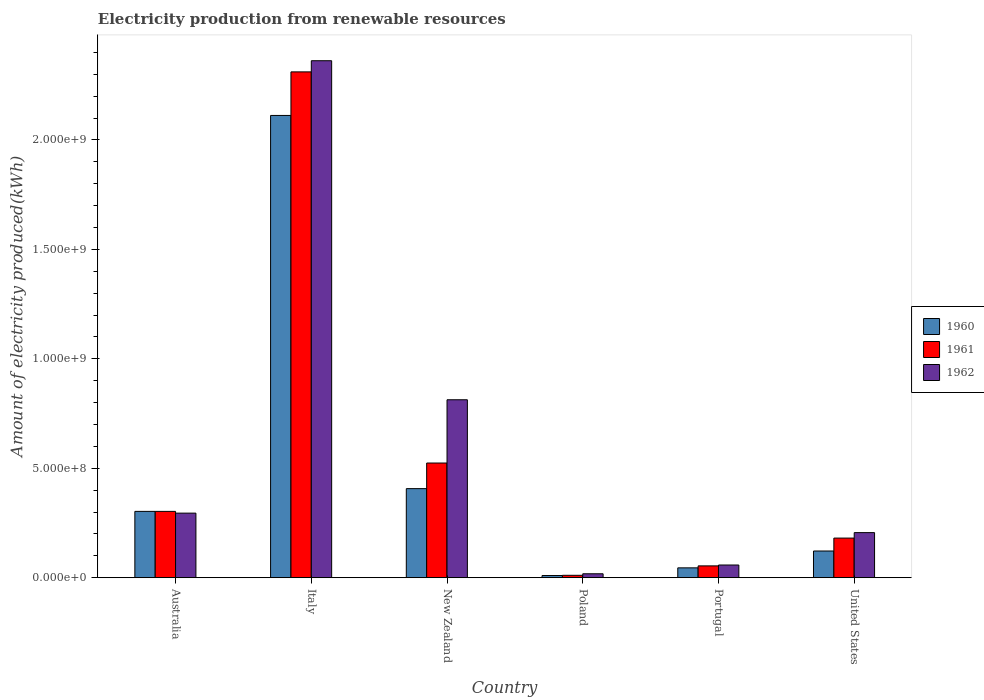How many different coloured bars are there?
Ensure brevity in your answer.  3. How many groups of bars are there?
Keep it short and to the point. 6. Are the number of bars per tick equal to the number of legend labels?
Ensure brevity in your answer.  Yes. How many bars are there on the 1st tick from the right?
Provide a succinct answer. 3. What is the label of the 1st group of bars from the left?
Provide a succinct answer. Australia. In how many cases, is the number of bars for a given country not equal to the number of legend labels?
Make the answer very short. 0. What is the amount of electricity produced in 1961 in United States?
Ensure brevity in your answer.  1.81e+08. Across all countries, what is the maximum amount of electricity produced in 1962?
Make the answer very short. 2.36e+09. Across all countries, what is the minimum amount of electricity produced in 1960?
Make the answer very short. 1.00e+07. In which country was the amount of electricity produced in 1960 maximum?
Ensure brevity in your answer.  Italy. What is the total amount of electricity produced in 1960 in the graph?
Offer a very short reply. 3.00e+09. What is the difference between the amount of electricity produced in 1962 in Italy and that in United States?
Provide a short and direct response. 2.16e+09. What is the difference between the amount of electricity produced in 1961 in New Zealand and the amount of electricity produced in 1960 in Portugal?
Keep it short and to the point. 4.79e+08. What is the average amount of electricity produced in 1962 per country?
Offer a terse response. 6.25e+08. What is the difference between the amount of electricity produced of/in 1961 and amount of electricity produced of/in 1962 in Australia?
Keep it short and to the point. 8.00e+06. In how many countries, is the amount of electricity produced in 1961 greater than 1900000000 kWh?
Your answer should be compact. 1. What is the ratio of the amount of electricity produced in 1962 in Italy to that in Portugal?
Your response must be concise. 40.72. Is the amount of electricity produced in 1961 in Italy less than that in Portugal?
Ensure brevity in your answer.  No. What is the difference between the highest and the second highest amount of electricity produced in 1961?
Offer a terse response. 1.79e+09. What is the difference between the highest and the lowest amount of electricity produced in 1962?
Ensure brevity in your answer.  2.34e+09. In how many countries, is the amount of electricity produced in 1960 greater than the average amount of electricity produced in 1960 taken over all countries?
Offer a very short reply. 1. Is the sum of the amount of electricity produced in 1962 in Australia and Poland greater than the maximum amount of electricity produced in 1960 across all countries?
Your answer should be very brief. No. What does the 1st bar from the left in Portugal represents?
Ensure brevity in your answer.  1960. Is it the case that in every country, the sum of the amount of electricity produced in 1961 and amount of electricity produced in 1960 is greater than the amount of electricity produced in 1962?
Give a very brief answer. Yes. How many bars are there?
Offer a terse response. 18. Are all the bars in the graph horizontal?
Provide a short and direct response. No. Are the values on the major ticks of Y-axis written in scientific E-notation?
Keep it short and to the point. Yes. How many legend labels are there?
Give a very brief answer. 3. How are the legend labels stacked?
Your response must be concise. Vertical. What is the title of the graph?
Your answer should be compact. Electricity production from renewable resources. What is the label or title of the X-axis?
Give a very brief answer. Country. What is the label or title of the Y-axis?
Offer a terse response. Amount of electricity produced(kWh). What is the Amount of electricity produced(kWh) of 1960 in Australia?
Ensure brevity in your answer.  3.03e+08. What is the Amount of electricity produced(kWh) of 1961 in Australia?
Offer a terse response. 3.03e+08. What is the Amount of electricity produced(kWh) in 1962 in Australia?
Your answer should be compact. 2.95e+08. What is the Amount of electricity produced(kWh) in 1960 in Italy?
Your answer should be very brief. 2.11e+09. What is the Amount of electricity produced(kWh) of 1961 in Italy?
Your answer should be very brief. 2.31e+09. What is the Amount of electricity produced(kWh) of 1962 in Italy?
Your answer should be compact. 2.36e+09. What is the Amount of electricity produced(kWh) in 1960 in New Zealand?
Offer a very short reply. 4.07e+08. What is the Amount of electricity produced(kWh) in 1961 in New Zealand?
Make the answer very short. 5.24e+08. What is the Amount of electricity produced(kWh) of 1962 in New Zealand?
Make the answer very short. 8.13e+08. What is the Amount of electricity produced(kWh) of 1961 in Poland?
Provide a succinct answer. 1.10e+07. What is the Amount of electricity produced(kWh) of 1962 in Poland?
Provide a succinct answer. 1.80e+07. What is the Amount of electricity produced(kWh) of 1960 in Portugal?
Offer a terse response. 4.50e+07. What is the Amount of electricity produced(kWh) of 1961 in Portugal?
Keep it short and to the point. 5.40e+07. What is the Amount of electricity produced(kWh) of 1962 in Portugal?
Your answer should be compact. 5.80e+07. What is the Amount of electricity produced(kWh) in 1960 in United States?
Provide a short and direct response. 1.22e+08. What is the Amount of electricity produced(kWh) in 1961 in United States?
Your response must be concise. 1.81e+08. What is the Amount of electricity produced(kWh) in 1962 in United States?
Make the answer very short. 2.06e+08. Across all countries, what is the maximum Amount of electricity produced(kWh) of 1960?
Make the answer very short. 2.11e+09. Across all countries, what is the maximum Amount of electricity produced(kWh) of 1961?
Make the answer very short. 2.31e+09. Across all countries, what is the maximum Amount of electricity produced(kWh) of 1962?
Make the answer very short. 2.36e+09. Across all countries, what is the minimum Amount of electricity produced(kWh) in 1961?
Offer a terse response. 1.10e+07. Across all countries, what is the minimum Amount of electricity produced(kWh) in 1962?
Keep it short and to the point. 1.80e+07. What is the total Amount of electricity produced(kWh) in 1960 in the graph?
Keep it short and to the point. 3.00e+09. What is the total Amount of electricity produced(kWh) of 1961 in the graph?
Your answer should be very brief. 3.38e+09. What is the total Amount of electricity produced(kWh) of 1962 in the graph?
Ensure brevity in your answer.  3.75e+09. What is the difference between the Amount of electricity produced(kWh) in 1960 in Australia and that in Italy?
Your answer should be very brief. -1.81e+09. What is the difference between the Amount of electricity produced(kWh) of 1961 in Australia and that in Italy?
Give a very brief answer. -2.01e+09. What is the difference between the Amount of electricity produced(kWh) of 1962 in Australia and that in Italy?
Offer a terse response. -2.07e+09. What is the difference between the Amount of electricity produced(kWh) in 1960 in Australia and that in New Zealand?
Make the answer very short. -1.04e+08. What is the difference between the Amount of electricity produced(kWh) of 1961 in Australia and that in New Zealand?
Your response must be concise. -2.21e+08. What is the difference between the Amount of electricity produced(kWh) in 1962 in Australia and that in New Zealand?
Keep it short and to the point. -5.18e+08. What is the difference between the Amount of electricity produced(kWh) in 1960 in Australia and that in Poland?
Make the answer very short. 2.93e+08. What is the difference between the Amount of electricity produced(kWh) of 1961 in Australia and that in Poland?
Your answer should be compact. 2.92e+08. What is the difference between the Amount of electricity produced(kWh) of 1962 in Australia and that in Poland?
Keep it short and to the point. 2.77e+08. What is the difference between the Amount of electricity produced(kWh) in 1960 in Australia and that in Portugal?
Offer a very short reply. 2.58e+08. What is the difference between the Amount of electricity produced(kWh) of 1961 in Australia and that in Portugal?
Your response must be concise. 2.49e+08. What is the difference between the Amount of electricity produced(kWh) of 1962 in Australia and that in Portugal?
Give a very brief answer. 2.37e+08. What is the difference between the Amount of electricity produced(kWh) in 1960 in Australia and that in United States?
Offer a terse response. 1.81e+08. What is the difference between the Amount of electricity produced(kWh) of 1961 in Australia and that in United States?
Provide a short and direct response. 1.22e+08. What is the difference between the Amount of electricity produced(kWh) in 1962 in Australia and that in United States?
Your answer should be very brief. 8.90e+07. What is the difference between the Amount of electricity produced(kWh) of 1960 in Italy and that in New Zealand?
Keep it short and to the point. 1.70e+09. What is the difference between the Amount of electricity produced(kWh) in 1961 in Italy and that in New Zealand?
Your answer should be very brief. 1.79e+09. What is the difference between the Amount of electricity produced(kWh) in 1962 in Italy and that in New Zealand?
Offer a terse response. 1.55e+09. What is the difference between the Amount of electricity produced(kWh) of 1960 in Italy and that in Poland?
Give a very brief answer. 2.10e+09. What is the difference between the Amount of electricity produced(kWh) in 1961 in Italy and that in Poland?
Make the answer very short. 2.30e+09. What is the difference between the Amount of electricity produced(kWh) in 1962 in Italy and that in Poland?
Ensure brevity in your answer.  2.34e+09. What is the difference between the Amount of electricity produced(kWh) of 1960 in Italy and that in Portugal?
Provide a short and direct response. 2.07e+09. What is the difference between the Amount of electricity produced(kWh) of 1961 in Italy and that in Portugal?
Provide a short and direct response. 2.26e+09. What is the difference between the Amount of electricity produced(kWh) of 1962 in Italy and that in Portugal?
Your response must be concise. 2.30e+09. What is the difference between the Amount of electricity produced(kWh) in 1960 in Italy and that in United States?
Make the answer very short. 1.99e+09. What is the difference between the Amount of electricity produced(kWh) in 1961 in Italy and that in United States?
Your answer should be compact. 2.13e+09. What is the difference between the Amount of electricity produced(kWh) of 1962 in Italy and that in United States?
Provide a short and direct response. 2.16e+09. What is the difference between the Amount of electricity produced(kWh) in 1960 in New Zealand and that in Poland?
Give a very brief answer. 3.97e+08. What is the difference between the Amount of electricity produced(kWh) in 1961 in New Zealand and that in Poland?
Your response must be concise. 5.13e+08. What is the difference between the Amount of electricity produced(kWh) of 1962 in New Zealand and that in Poland?
Your answer should be very brief. 7.95e+08. What is the difference between the Amount of electricity produced(kWh) of 1960 in New Zealand and that in Portugal?
Give a very brief answer. 3.62e+08. What is the difference between the Amount of electricity produced(kWh) in 1961 in New Zealand and that in Portugal?
Your answer should be compact. 4.70e+08. What is the difference between the Amount of electricity produced(kWh) in 1962 in New Zealand and that in Portugal?
Provide a short and direct response. 7.55e+08. What is the difference between the Amount of electricity produced(kWh) of 1960 in New Zealand and that in United States?
Keep it short and to the point. 2.85e+08. What is the difference between the Amount of electricity produced(kWh) in 1961 in New Zealand and that in United States?
Your response must be concise. 3.43e+08. What is the difference between the Amount of electricity produced(kWh) in 1962 in New Zealand and that in United States?
Keep it short and to the point. 6.07e+08. What is the difference between the Amount of electricity produced(kWh) of 1960 in Poland and that in Portugal?
Your answer should be very brief. -3.50e+07. What is the difference between the Amount of electricity produced(kWh) of 1961 in Poland and that in Portugal?
Offer a terse response. -4.30e+07. What is the difference between the Amount of electricity produced(kWh) of 1962 in Poland and that in Portugal?
Your response must be concise. -4.00e+07. What is the difference between the Amount of electricity produced(kWh) in 1960 in Poland and that in United States?
Give a very brief answer. -1.12e+08. What is the difference between the Amount of electricity produced(kWh) in 1961 in Poland and that in United States?
Make the answer very short. -1.70e+08. What is the difference between the Amount of electricity produced(kWh) of 1962 in Poland and that in United States?
Make the answer very short. -1.88e+08. What is the difference between the Amount of electricity produced(kWh) of 1960 in Portugal and that in United States?
Make the answer very short. -7.70e+07. What is the difference between the Amount of electricity produced(kWh) of 1961 in Portugal and that in United States?
Offer a terse response. -1.27e+08. What is the difference between the Amount of electricity produced(kWh) of 1962 in Portugal and that in United States?
Provide a succinct answer. -1.48e+08. What is the difference between the Amount of electricity produced(kWh) in 1960 in Australia and the Amount of electricity produced(kWh) in 1961 in Italy?
Provide a succinct answer. -2.01e+09. What is the difference between the Amount of electricity produced(kWh) in 1960 in Australia and the Amount of electricity produced(kWh) in 1962 in Italy?
Your answer should be very brief. -2.06e+09. What is the difference between the Amount of electricity produced(kWh) of 1961 in Australia and the Amount of electricity produced(kWh) of 1962 in Italy?
Provide a short and direct response. -2.06e+09. What is the difference between the Amount of electricity produced(kWh) in 1960 in Australia and the Amount of electricity produced(kWh) in 1961 in New Zealand?
Provide a succinct answer. -2.21e+08. What is the difference between the Amount of electricity produced(kWh) in 1960 in Australia and the Amount of electricity produced(kWh) in 1962 in New Zealand?
Provide a succinct answer. -5.10e+08. What is the difference between the Amount of electricity produced(kWh) of 1961 in Australia and the Amount of electricity produced(kWh) of 1962 in New Zealand?
Your answer should be very brief. -5.10e+08. What is the difference between the Amount of electricity produced(kWh) of 1960 in Australia and the Amount of electricity produced(kWh) of 1961 in Poland?
Ensure brevity in your answer.  2.92e+08. What is the difference between the Amount of electricity produced(kWh) of 1960 in Australia and the Amount of electricity produced(kWh) of 1962 in Poland?
Offer a very short reply. 2.85e+08. What is the difference between the Amount of electricity produced(kWh) in 1961 in Australia and the Amount of electricity produced(kWh) in 1962 in Poland?
Keep it short and to the point. 2.85e+08. What is the difference between the Amount of electricity produced(kWh) in 1960 in Australia and the Amount of electricity produced(kWh) in 1961 in Portugal?
Provide a short and direct response. 2.49e+08. What is the difference between the Amount of electricity produced(kWh) of 1960 in Australia and the Amount of electricity produced(kWh) of 1962 in Portugal?
Your answer should be very brief. 2.45e+08. What is the difference between the Amount of electricity produced(kWh) of 1961 in Australia and the Amount of electricity produced(kWh) of 1962 in Portugal?
Keep it short and to the point. 2.45e+08. What is the difference between the Amount of electricity produced(kWh) in 1960 in Australia and the Amount of electricity produced(kWh) in 1961 in United States?
Keep it short and to the point. 1.22e+08. What is the difference between the Amount of electricity produced(kWh) in 1960 in Australia and the Amount of electricity produced(kWh) in 1962 in United States?
Your response must be concise. 9.70e+07. What is the difference between the Amount of electricity produced(kWh) of 1961 in Australia and the Amount of electricity produced(kWh) of 1962 in United States?
Make the answer very short. 9.70e+07. What is the difference between the Amount of electricity produced(kWh) in 1960 in Italy and the Amount of electricity produced(kWh) in 1961 in New Zealand?
Keep it short and to the point. 1.59e+09. What is the difference between the Amount of electricity produced(kWh) of 1960 in Italy and the Amount of electricity produced(kWh) of 1962 in New Zealand?
Keep it short and to the point. 1.30e+09. What is the difference between the Amount of electricity produced(kWh) in 1961 in Italy and the Amount of electricity produced(kWh) in 1962 in New Zealand?
Keep it short and to the point. 1.50e+09. What is the difference between the Amount of electricity produced(kWh) of 1960 in Italy and the Amount of electricity produced(kWh) of 1961 in Poland?
Your response must be concise. 2.10e+09. What is the difference between the Amount of electricity produced(kWh) of 1960 in Italy and the Amount of electricity produced(kWh) of 1962 in Poland?
Your response must be concise. 2.09e+09. What is the difference between the Amount of electricity produced(kWh) of 1961 in Italy and the Amount of electricity produced(kWh) of 1962 in Poland?
Your answer should be compact. 2.29e+09. What is the difference between the Amount of electricity produced(kWh) of 1960 in Italy and the Amount of electricity produced(kWh) of 1961 in Portugal?
Ensure brevity in your answer.  2.06e+09. What is the difference between the Amount of electricity produced(kWh) in 1960 in Italy and the Amount of electricity produced(kWh) in 1962 in Portugal?
Your answer should be very brief. 2.05e+09. What is the difference between the Amount of electricity produced(kWh) in 1961 in Italy and the Amount of electricity produced(kWh) in 1962 in Portugal?
Keep it short and to the point. 2.25e+09. What is the difference between the Amount of electricity produced(kWh) in 1960 in Italy and the Amount of electricity produced(kWh) in 1961 in United States?
Give a very brief answer. 1.93e+09. What is the difference between the Amount of electricity produced(kWh) in 1960 in Italy and the Amount of electricity produced(kWh) in 1962 in United States?
Offer a terse response. 1.91e+09. What is the difference between the Amount of electricity produced(kWh) in 1961 in Italy and the Amount of electricity produced(kWh) in 1962 in United States?
Give a very brief answer. 2.10e+09. What is the difference between the Amount of electricity produced(kWh) of 1960 in New Zealand and the Amount of electricity produced(kWh) of 1961 in Poland?
Ensure brevity in your answer.  3.96e+08. What is the difference between the Amount of electricity produced(kWh) in 1960 in New Zealand and the Amount of electricity produced(kWh) in 1962 in Poland?
Offer a very short reply. 3.89e+08. What is the difference between the Amount of electricity produced(kWh) in 1961 in New Zealand and the Amount of electricity produced(kWh) in 1962 in Poland?
Give a very brief answer. 5.06e+08. What is the difference between the Amount of electricity produced(kWh) in 1960 in New Zealand and the Amount of electricity produced(kWh) in 1961 in Portugal?
Provide a succinct answer. 3.53e+08. What is the difference between the Amount of electricity produced(kWh) of 1960 in New Zealand and the Amount of electricity produced(kWh) of 1962 in Portugal?
Ensure brevity in your answer.  3.49e+08. What is the difference between the Amount of electricity produced(kWh) of 1961 in New Zealand and the Amount of electricity produced(kWh) of 1962 in Portugal?
Make the answer very short. 4.66e+08. What is the difference between the Amount of electricity produced(kWh) of 1960 in New Zealand and the Amount of electricity produced(kWh) of 1961 in United States?
Ensure brevity in your answer.  2.26e+08. What is the difference between the Amount of electricity produced(kWh) of 1960 in New Zealand and the Amount of electricity produced(kWh) of 1962 in United States?
Give a very brief answer. 2.01e+08. What is the difference between the Amount of electricity produced(kWh) in 1961 in New Zealand and the Amount of electricity produced(kWh) in 1962 in United States?
Give a very brief answer. 3.18e+08. What is the difference between the Amount of electricity produced(kWh) in 1960 in Poland and the Amount of electricity produced(kWh) in 1961 in Portugal?
Keep it short and to the point. -4.40e+07. What is the difference between the Amount of electricity produced(kWh) of 1960 in Poland and the Amount of electricity produced(kWh) of 1962 in Portugal?
Provide a short and direct response. -4.80e+07. What is the difference between the Amount of electricity produced(kWh) of 1961 in Poland and the Amount of electricity produced(kWh) of 1962 in Portugal?
Your answer should be very brief. -4.70e+07. What is the difference between the Amount of electricity produced(kWh) in 1960 in Poland and the Amount of electricity produced(kWh) in 1961 in United States?
Keep it short and to the point. -1.71e+08. What is the difference between the Amount of electricity produced(kWh) in 1960 in Poland and the Amount of electricity produced(kWh) in 1962 in United States?
Your response must be concise. -1.96e+08. What is the difference between the Amount of electricity produced(kWh) in 1961 in Poland and the Amount of electricity produced(kWh) in 1962 in United States?
Provide a succinct answer. -1.95e+08. What is the difference between the Amount of electricity produced(kWh) of 1960 in Portugal and the Amount of electricity produced(kWh) of 1961 in United States?
Your answer should be compact. -1.36e+08. What is the difference between the Amount of electricity produced(kWh) of 1960 in Portugal and the Amount of electricity produced(kWh) of 1962 in United States?
Provide a short and direct response. -1.61e+08. What is the difference between the Amount of electricity produced(kWh) of 1961 in Portugal and the Amount of electricity produced(kWh) of 1962 in United States?
Make the answer very short. -1.52e+08. What is the average Amount of electricity produced(kWh) of 1960 per country?
Give a very brief answer. 5.00e+08. What is the average Amount of electricity produced(kWh) in 1961 per country?
Make the answer very short. 5.64e+08. What is the average Amount of electricity produced(kWh) in 1962 per country?
Provide a short and direct response. 6.25e+08. What is the difference between the Amount of electricity produced(kWh) of 1960 and Amount of electricity produced(kWh) of 1961 in Italy?
Your answer should be compact. -1.99e+08. What is the difference between the Amount of electricity produced(kWh) of 1960 and Amount of electricity produced(kWh) of 1962 in Italy?
Provide a short and direct response. -2.50e+08. What is the difference between the Amount of electricity produced(kWh) of 1961 and Amount of electricity produced(kWh) of 1962 in Italy?
Provide a succinct answer. -5.10e+07. What is the difference between the Amount of electricity produced(kWh) in 1960 and Amount of electricity produced(kWh) in 1961 in New Zealand?
Offer a terse response. -1.17e+08. What is the difference between the Amount of electricity produced(kWh) of 1960 and Amount of electricity produced(kWh) of 1962 in New Zealand?
Keep it short and to the point. -4.06e+08. What is the difference between the Amount of electricity produced(kWh) in 1961 and Amount of electricity produced(kWh) in 1962 in New Zealand?
Your answer should be very brief. -2.89e+08. What is the difference between the Amount of electricity produced(kWh) of 1960 and Amount of electricity produced(kWh) of 1962 in Poland?
Make the answer very short. -8.00e+06. What is the difference between the Amount of electricity produced(kWh) in 1961 and Amount of electricity produced(kWh) in 1962 in Poland?
Keep it short and to the point. -7.00e+06. What is the difference between the Amount of electricity produced(kWh) in 1960 and Amount of electricity produced(kWh) in 1961 in Portugal?
Provide a succinct answer. -9.00e+06. What is the difference between the Amount of electricity produced(kWh) in 1960 and Amount of electricity produced(kWh) in 1962 in Portugal?
Your response must be concise. -1.30e+07. What is the difference between the Amount of electricity produced(kWh) of 1960 and Amount of electricity produced(kWh) of 1961 in United States?
Provide a succinct answer. -5.90e+07. What is the difference between the Amount of electricity produced(kWh) of 1960 and Amount of electricity produced(kWh) of 1962 in United States?
Provide a succinct answer. -8.40e+07. What is the difference between the Amount of electricity produced(kWh) in 1961 and Amount of electricity produced(kWh) in 1962 in United States?
Provide a short and direct response. -2.50e+07. What is the ratio of the Amount of electricity produced(kWh) of 1960 in Australia to that in Italy?
Ensure brevity in your answer.  0.14. What is the ratio of the Amount of electricity produced(kWh) of 1961 in Australia to that in Italy?
Offer a terse response. 0.13. What is the ratio of the Amount of electricity produced(kWh) in 1962 in Australia to that in Italy?
Give a very brief answer. 0.12. What is the ratio of the Amount of electricity produced(kWh) in 1960 in Australia to that in New Zealand?
Offer a very short reply. 0.74. What is the ratio of the Amount of electricity produced(kWh) of 1961 in Australia to that in New Zealand?
Your response must be concise. 0.58. What is the ratio of the Amount of electricity produced(kWh) in 1962 in Australia to that in New Zealand?
Your answer should be compact. 0.36. What is the ratio of the Amount of electricity produced(kWh) of 1960 in Australia to that in Poland?
Ensure brevity in your answer.  30.3. What is the ratio of the Amount of electricity produced(kWh) in 1961 in Australia to that in Poland?
Give a very brief answer. 27.55. What is the ratio of the Amount of electricity produced(kWh) in 1962 in Australia to that in Poland?
Ensure brevity in your answer.  16.39. What is the ratio of the Amount of electricity produced(kWh) in 1960 in Australia to that in Portugal?
Give a very brief answer. 6.73. What is the ratio of the Amount of electricity produced(kWh) in 1961 in Australia to that in Portugal?
Provide a succinct answer. 5.61. What is the ratio of the Amount of electricity produced(kWh) in 1962 in Australia to that in Portugal?
Give a very brief answer. 5.09. What is the ratio of the Amount of electricity produced(kWh) of 1960 in Australia to that in United States?
Offer a very short reply. 2.48. What is the ratio of the Amount of electricity produced(kWh) of 1961 in Australia to that in United States?
Ensure brevity in your answer.  1.67. What is the ratio of the Amount of electricity produced(kWh) of 1962 in Australia to that in United States?
Ensure brevity in your answer.  1.43. What is the ratio of the Amount of electricity produced(kWh) in 1960 in Italy to that in New Zealand?
Provide a succinct answer. 5.19. What is the ratio of the Amount of electricity produced(kWh) in 1961 in Italy to that in New Zealand?
Keep it short and to the point. 4.41. What is the ratio of the Amount of electricity produced(kWh) in 1962 in Italy to that in New Zealand?
Your response must be concise. 2.91. What is the ratio of the Amount of electricity produced(kWh) in 1960 in Italy to that in Poland?
Your response must be concise. 211.2. What is the ratio of the Amount of electricity produced(kWh) of 1961 in Italy to that in Poland?
Keep it short and to the point. 210.09. What is the ratio of the Amount of electricity produced(kWh) in 1962 in Italy to that in Poland?
Your response must be concise. 131.22. What is the ratio of the Amount of electricity produced(kWh) in 1960 in Italy to that in Portugal?
Ensure brevity in your answer.  46.93. What is the ratio of the Amount of electricity produced(kWh) of 1961 in Italy to that in Portugal?
Your answer should be very brief. 42.8. What is the ratio of the Amount of electricity produced(kWh) of 1962 in Italy to that in Portugal?
Offer a very short reply. 40.72. What is the ratio of the Amount of electricity produced(kWh) in 1960 in Italy to that in United States?
Ensure brevity in your answer.  17.31. What is the ratio of the Amount of electricity produced(kWh) of 1961 in Italy to that in United States?
Provide a succinct answer. 12.77. What is the ratio of the Amount of electricity produced(kWh) in 1962 in Italy to that in United States?
Your answer should be very brief. 11.47. What is the ratio of the Amount of electricity produced(kWh) in 1960 in New Zealand to that in Poland?
Ensure brevity in your answer.  40.7. What is the ratio of the Amount of electricity produced(kWh) in 1961 in New Zealand to that in Poland?
Your answer should be compact. 47.64. What is the ratio of the Amount of electricity produced(kWh) in 1962 in New Zealand to that in Poland?
Provide a succinct answer. 45.17. What is the ratio of the Amount of electricity produced(kWh) in 1960 in New Zealand to that in Portugal?
Your response must be concise. 9.04. What is the ratio of the Amount of electricity produced(kWh) in 1961 in New Zealand to that in Portugal?
Give a very brief answer. 9.7. What is the ratio of the Amount of electricity produced(kWh) in 1962 in New Zealand to that in Portugal?
Make the answer very short. 14.02. What is the ratio of the Amount of electricity produced(kWh) of 1960 in New Zealand to that in United States?
Your answer should be very brief. 3.34. What is the ratio of the Amount of electricity produced(kWh) in 1961 in New Zealand to that in United States?
Your response must be concise. 2.9. What is the ratio of the Amount of electricity produced(kWh) in 1962 in New Zealand to that in United States?
Make the answer very short. 3.95. What is the ratio of the Amount of electricity produced(kWh) of 1960 in Poland to that in Portugal?
Offer a very short reply. 0.22. What is the ratio of the Amount of electricity produced(kWh) of 1961 in Poland to that in Portugal?
Give a very brief answer. 0.2. What is the ratio of the Amount of electricity produced(kWh) of 1962 in Poland to that in Portugal?
Make the answer very short. 0.31. What is the ratio of the Amount of electricity produced(kWh) of 1960 in Poland to that in United States?
Your answer should be very brief. 0.08. What is the ratio of the Amount of electricity produced(kWh) of 1961 in Poland to that in United States?
Make the answer very short. 0.06. What is the ratio of the Amount of electricity produced(kWh) in 1962 in Poland to that in United States?
Provide a succinct answer. 0.09. What is the ratio of the Amount of electricity produced(kWh) of 1960 in Portugal to that in United States?
Give a very brief answer. 0.37. What is the ratio of the Amount of electricity produced(kWh) of 1961 in Portugal to that in United States?
Your answer should be compact. 0.3. What is the ratio of the Amount of electricity produced(kWh) of 1962 in Portugal to that in United States?
Provide a short and direct response. 0.28. What is the difference between the highest and the second highest Amount of electricity produced(kWh) of 1960?
Provide a short and direct response. 1.70e+09. What is the difference between the highest and the second highest Amount of electricity produced(kWh) of 1961?
Your response must be concise. 1.79e+09. What is the difference between the highest and the second highest Amount of electricity produced(kWh) of 1962?
Provide a succinct answer. 1.55e+09. What is the difference between the highest and the lowest Amount of electricity produced(kWh) in 1960?
Your answer should be compact. 2.10e+09. What is the difference between the highest and the lowest Amount of electricity produced(kWh) of 1961?
Ensure brevity in your answer.  2.30e+09. What is the difference between the highest and the lowest Amount of electricity produced(kWh) of 1962?
Your answer should be very brief. 2.34e+09. 